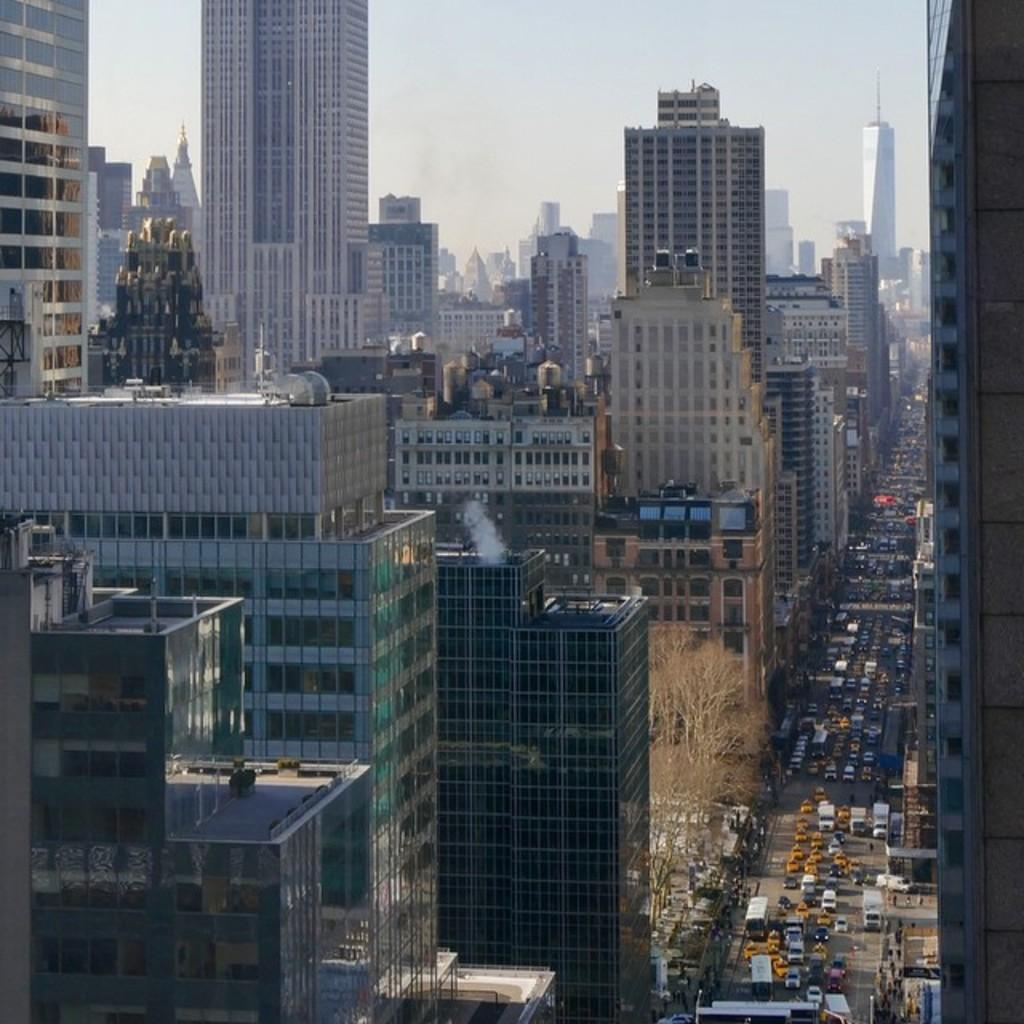What can be seen in the image? There are vehicles in the image. What is visible in the background of the image? There are buildings in the background of the image. What colors are the buildings? The buildings are in white and brown colors. What is visible above the buildings? The sky is visible in the image and is white in color. What type of lace is used to decorate the vehicles in the image? There is no lace present on the vehicles in the image. What system is responsible for the functioning of the buildings in the image? The provided facts do not mention any system responsible for the functioning of the buildings in the image. 